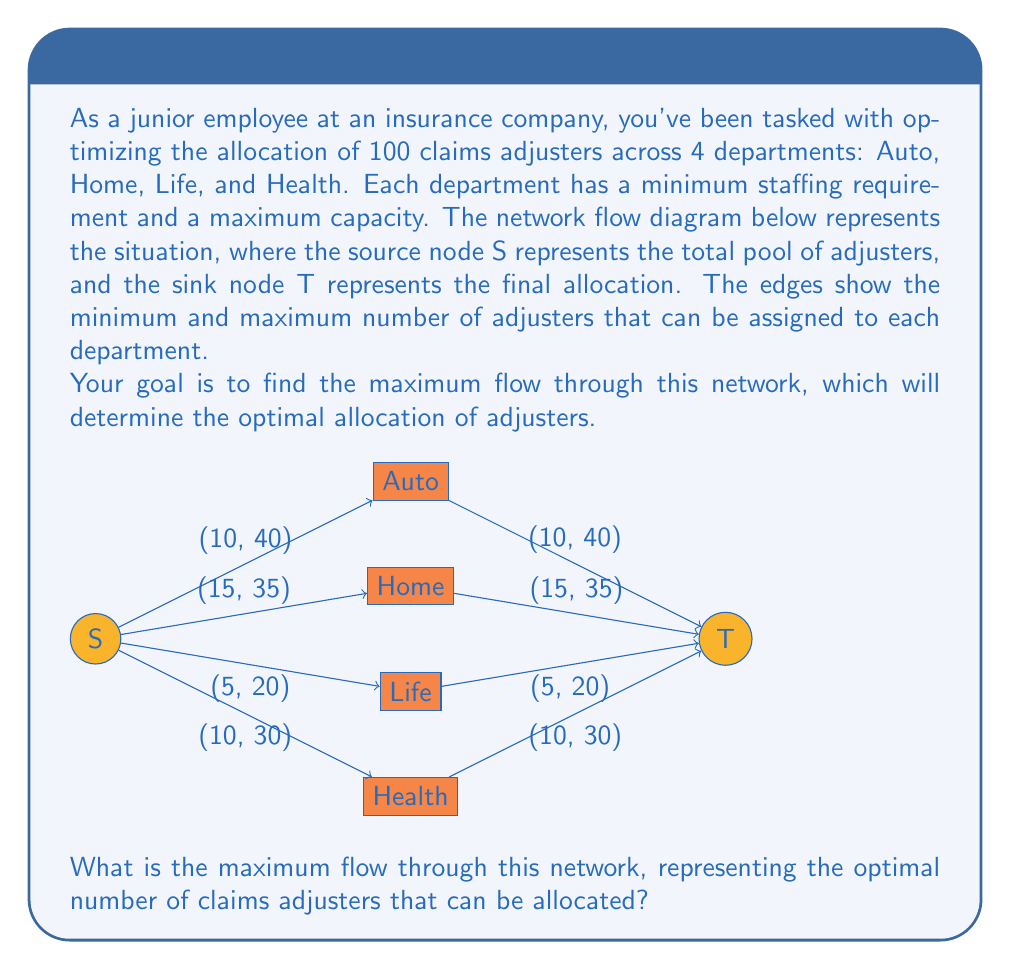Teach me how to tackle this problem. To solve this maximum flow problem, we can use the Ford-Fulkerson algorithm or its improvement, the Edmonds-Karp algorithm. However, for this relatively simple network, we can solve it by inspection and logical reasoning:

1) First, note that the total number of adjusters (100) is more than the sum of all minimum requirements (10 + 15 + 5 + 10 = 40), but less than the sum of all maximum capacities (40 + 35 + 20 + 30 = 125).

2) This means that all minimum requirements can be met, but not all departments can be filled to capacity.

3) The optimal solution will satisfy the following conditions:
   a) Each department receives at least its minimum requirement.
   b) No department exceeds its maximum capacity.
   c) The sum of all allocations equals the total number of adjusters (100).

4) Let's allocate the minimum to each department first:
   Auto: 10, Home: 15, Life: 5, Health: 10
   Total allocated so far: 40

5) We have 60 adjusters left to allocate (100 - 40 = 60).

6) Now, let's allocate the remaining adjusters to maximize the flow:
   - Auto can take 30 more (up to its max of 40)
   - Home can take 20 more (up to its max of 35)
   - Life can take 15 more (up to its max of 20)
   - Health can take 20 more (up to its max of 30)

7) The sum of these additional capacities (30 + 20 + 15 + 20 = 85) is more than the 60 we have left, so we can allocate all 60.

8) To maximize the flow, we allocate the remaining 60 in order of the largest additional capacity:
   - Auto: +30 (now at 40)
   - Home: +20 (now at 35)
   - Health: +10 (now at 20)

9) The final allocation is:
   Auto: 40, Home: 35, Life: 5, Health: 20
   Total: 40 + 35 + 5 + 20 = 100

Therefore, the maximum flow through this network is 100, which represents the optimal allocation of all 100 claims adjusters.
Answer: 100 